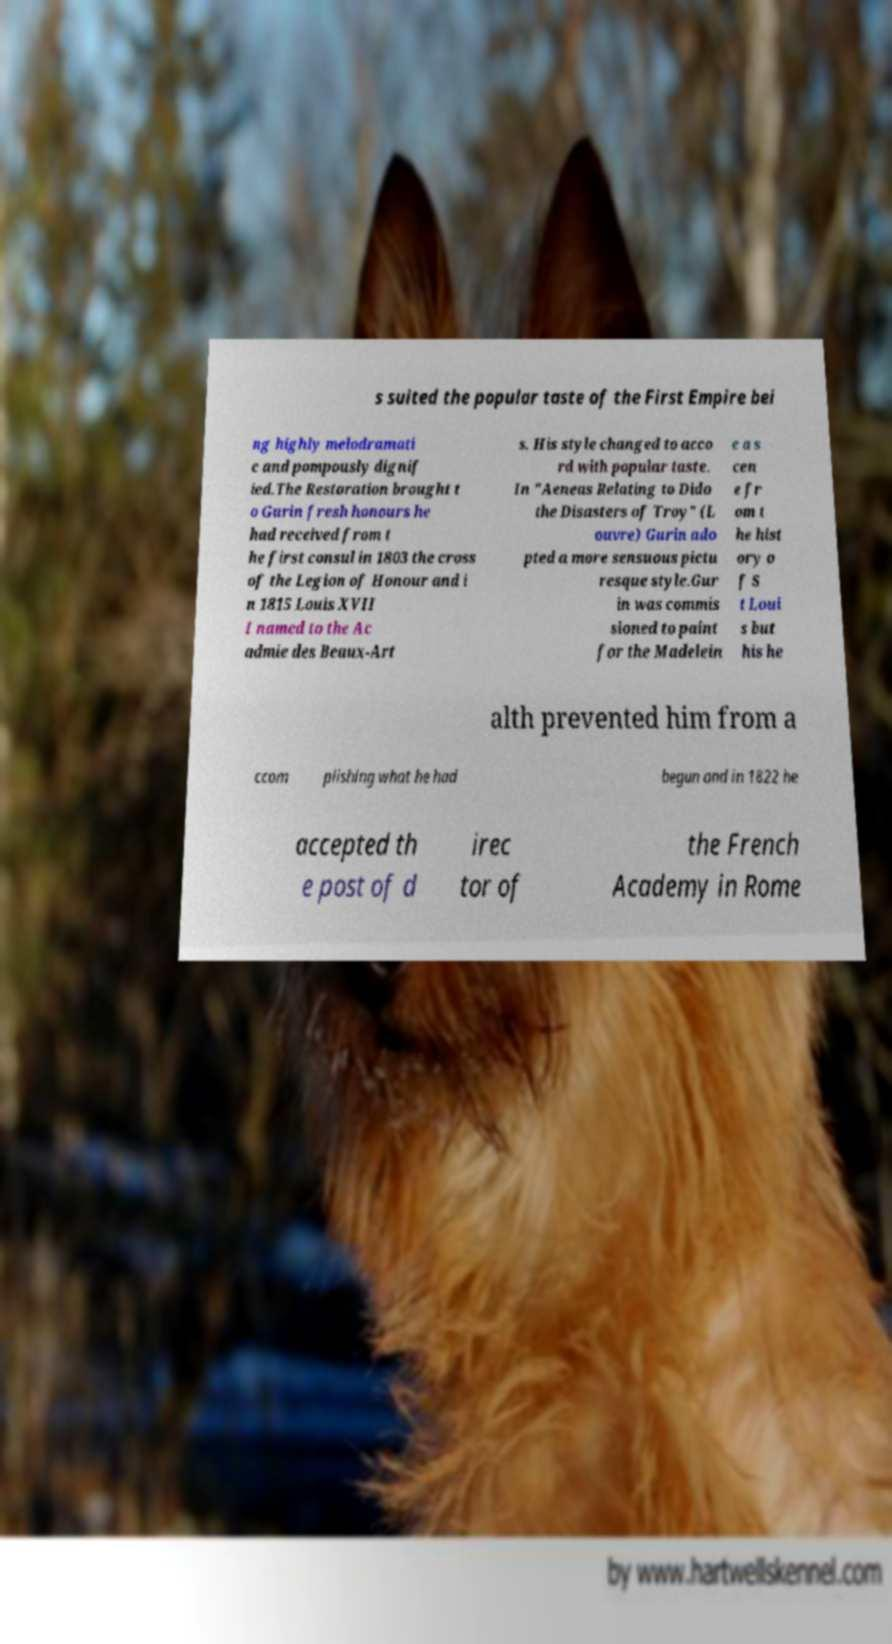Please identify and transcribe the text found in this image. s suited the popular taste of the First Empire bei ng highly melodramati c and pompously dignif ied.The Restoration brought t o Gurin fresh honours he had received from t he first consul in 1803 the cross of the Legion of Honour and i n 1815 Louis XVII I named to the Ac admie des Beaux-Art s. His style changed to acco rd with popular taste. In "Aeneas Relating to Dido the Disasters of Troy" (L ouvre) Gurin ado pted a more sensuous pictu resque style.Gur in was commis sioned to paint for the Madelein e a s cen e fr om t he hist ory o f S t Loui s but his he alth prevented him from a ccom plishing what he had begun and in 1822 he accepted th e post of d irec tor of the French Academy in Rome 